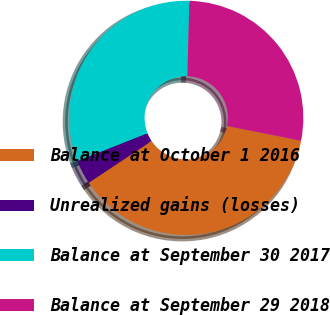Convert chart. <chart><loc_0><loc_0><loc_500><loc_500><pie_chart><fcel>Balance at October 1 2016<fcel>Unrealized gains (losses)<fcel>Balance at September 30 2017<fcel>Balance at September 29 2018<nl><fcel>37.54%<fcel>3.34%<fcel>31.43%<fcel>27.7%<nl></chart> 